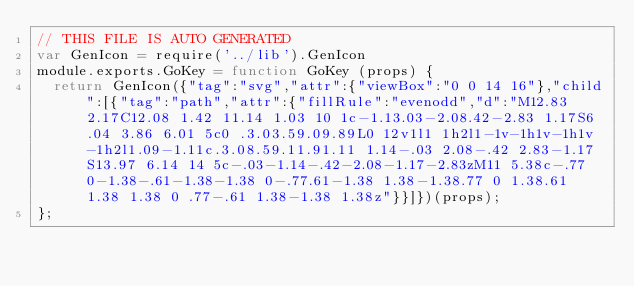Convert code to text. <code><loc_0><loc_0><loc_500><loc_500><_JavaScript_>// THIS FILE IS AUTO GENERATED
var GenIcon = require('../lib').GenIcon
module.exports.GoKey = function GoKey (props) {
  return GenIcon({"tag":"svg","attr":{"viewBox":"0 0 14 16"},"child":[{"tag":"path","attr":{"fillRule":"evenodd","d":"M12.83 2.17C12.08 1.42 11.14 1.03 10 1c-1.13.03-2.08.42-2.83 1.17S6.04 3.86 6.01 5c0 .3.03.59.09.89L0 12v1l1 1h2l1-1v-1h1v-1h1v-1h2l1.09-1.11c.3.08.59.11.91.11 1.14-.03 2.08-.42 2.83-1.17S13.97 6.14 14 5c-.03-1.14-.42-2.08-1.17-2.83zM11 5.38c-.77 0-1.38-.61-1.38-1.38 0-.77.61-1.38 1.38-1.38.77 0 1.38.61 1.38 1.38 0 .77-.61 1.38-1.38 1.38z"}}]})(props);
};
</code> 